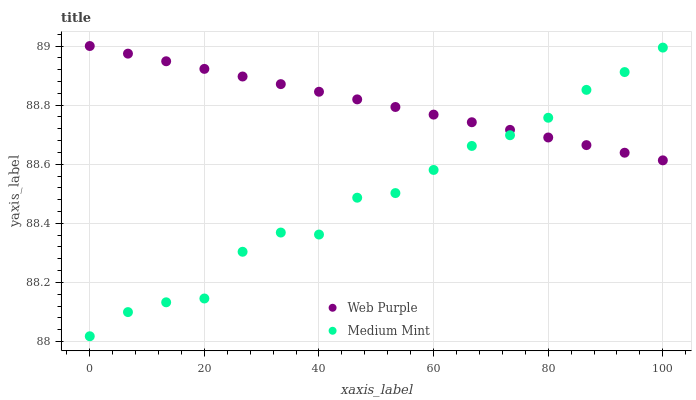Does Medium Mint have the minimum area under the curve?
Answer yes or no. Yes. Does Web Purple have the maximum area under the curve?
Answer yes or no. Yes. Does Web Purple have the minimum area under the curve?
Answer yes or no. No. Is Web Purple the smoothest?
Answer yes or no. Yes. Is Medium Mint the roughest?
Answer yes or no. Yes. Is Web Purple the roughest?
Answer yes or no. No. Does Medium Mint have the lowest value?
Answer yes or no. Yes. Does Web Purple have the lowest value?
Answer yes or no. No. Does Web Purple have the highest value?
Answer yes or no. Yes. Does Web Purple intersect Medium Mint?
Answer yes or no. Yes. Is Web Purple less than Medium Mint?
Answer yes or no. No. Is Web Purple greater than Medium Mint?
Answer yes or no. No. 